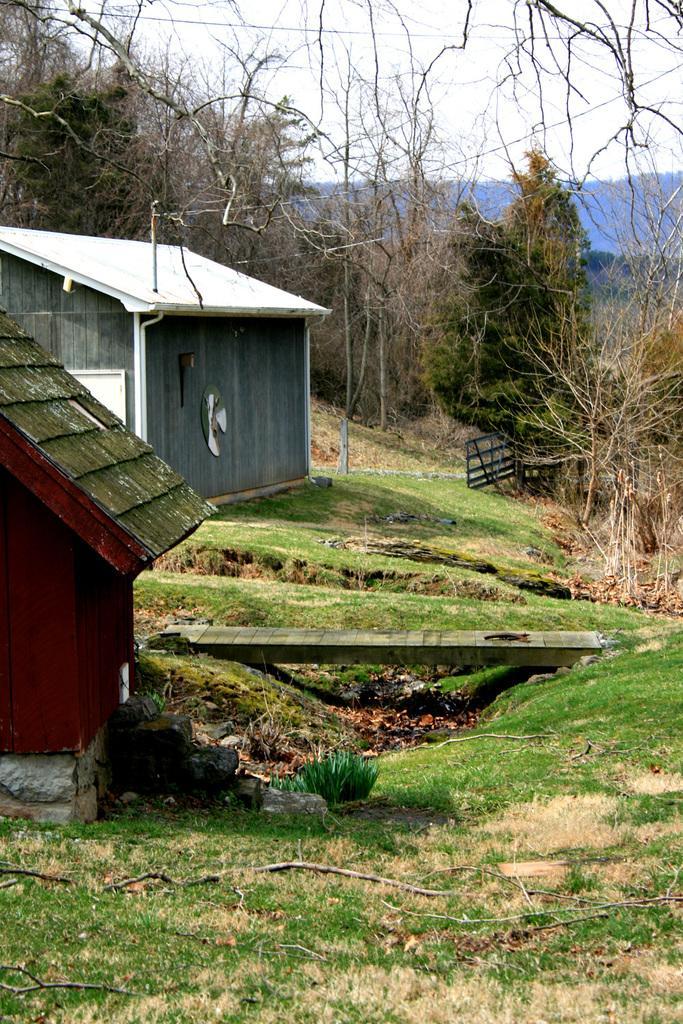In one or two sentences, can you explain what this image depicts? At the bottom of the image there is grass, on the left side of the image there are two sheds. Behind the sheds there are some trees and poles. At the top of the image there is sky. 